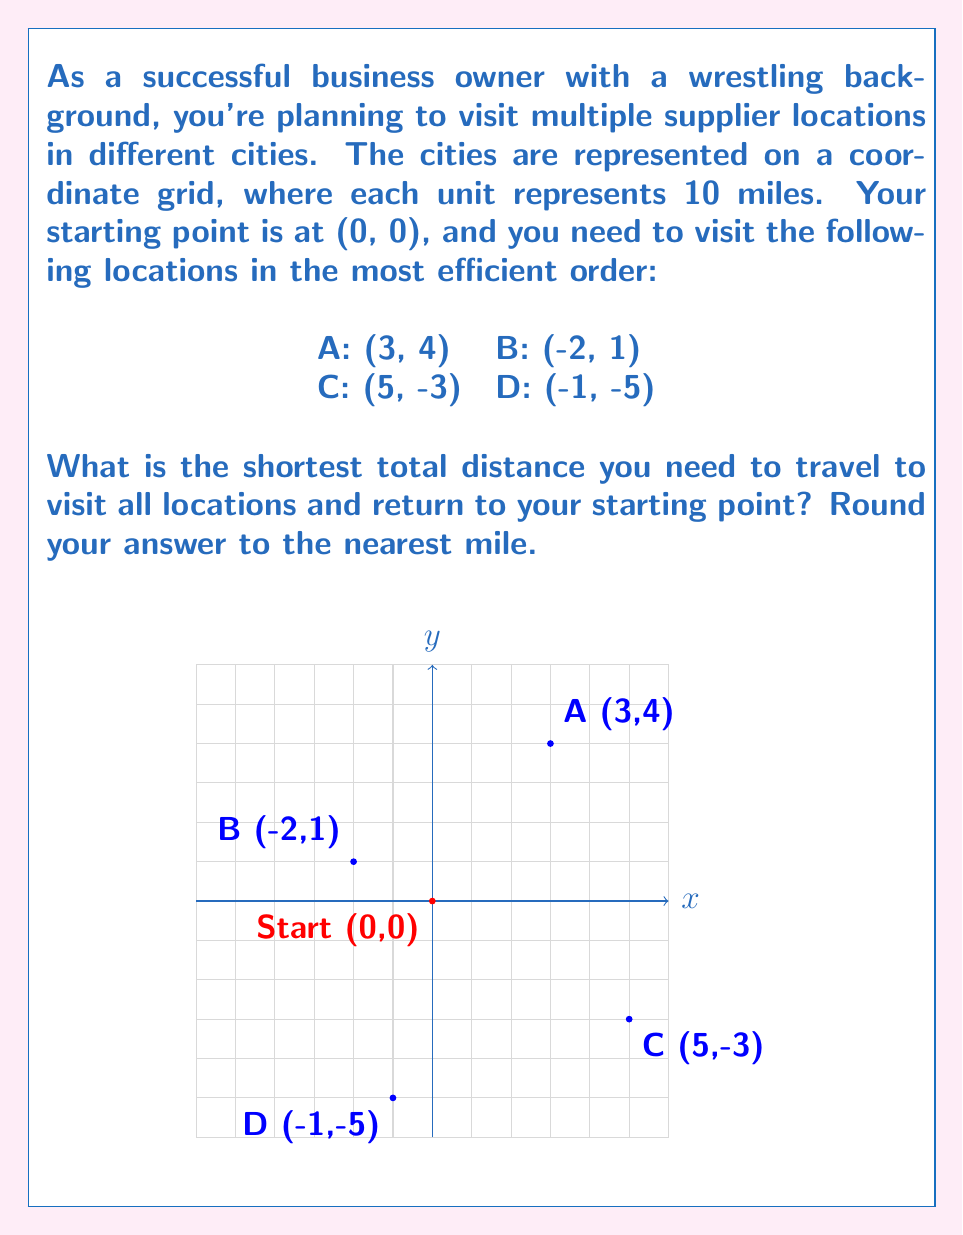Solve this math problem. Let's approach this step-by-step using the principles of the Traveling Salesman Problem:

1) First, we need to calculate the distances between all points. We can use the distance formula:
   $$d = \sqrt{(x_2-x_1)^2 + (y_2-y_1)^2}$$

2) Let's calculate these distances (in units):
   Start to A: $\sqrt{3^2 + 4^2} = 5$
   Start to B: $\sqrt{(-2)^2 + 1^2} = \sqrt{5}$
   Start to C: $\sqrt{5^2 + (-3)^2} = \sqrt{34}$
   Start to D: $\sqrt{(-1)^2 + (-5)^2} = \sqrt{26}$
   A to B: $\sqrt{5^2 + 3^2} = \sqrt{34}$
   A to C: $\sqrt{2^2 + (-7)^2} = \sqrt{53}$
   A to D: $\sqrt{4^2 + (-9)^2} = \sqrt{97}$
   B to C: $\sqrt{7^2 + (-4)^2} = \sqrt{65}$
   B to D: $\sqrt{1^2 + (-6)^2} = \sqrt{37}$
   C to D: $\sqrt{6^2 + (-2)^2} = \sqrt{40}$

3) Now, we need to find the shortest route that visits all points and returns to the start. We can do this by trying all possible permutations:

   Start-A-B-C-D-Start: $5 + \sqrt{34} + \sqrt{65} + \sqrt{40} + \sqrt{26} \approx 22.97$
   Start-A-B-D-C-Start: $5 + \sqrt{34} + \sqrt{37} + \sqrt{40} + \sqrt{34} \approx 23.10$
   Start-A-C-B-D-Start: $5 + \sqrt{53} + \sqrt{65} + \sqrt{37} + \sqrt{26} \approx 24.85$
   Start-A-C-D-B-Start: $5 + \sqrt{53} + \sqrt{40} + \sqrt{37} + \sqrt{5} \approx 22.76$
   Start-A-D-B-C-Start: $5 + \sqrt{97} + \sqrt{37} + \sqrt{65} + \sqrt{34} \approx 26.41$
   Start-A-D-C-B-Start: $5 + \sqrt{97} + \sqrt{40} + \sqrt{65} + \sqrt{5} \approx 25.07$

   (We've calculated all permutations starting with A; the shortest route will be among these due to symmetry)

4) The shortest route is Start-A-C-D-B-Start, with a total distance of approximately 22.76 units.

5) Since each unit represents 10 miles, we multiply our result by 10:
   $22.76 * 10 = 227.6$ miles

6) Rounding to the nearest mile, we get 228 miles.
Answer: 228 miles 